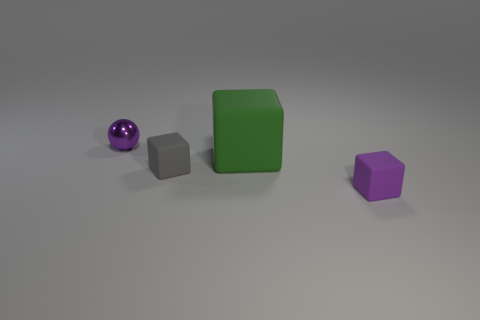Is there anything else that is the same size as the green matte thing?
Ensure brevity in your answer.  No. What is the size of the gray matte object?
Give a very brief answer. Small. There is a purple metal object that is left of the gray block; how big is it?
Give a very brief answer. Small. Does the object left of the gray object have the same size as the gray matte cube?
Ensure brevity in your answer.  Yes. Is there any other thing that is the same color as the metallic thing?
Make the answer very short. Yes. What is the shape of the big thing?
Keep it short and to the point. Cube. How many things are both to the left of the purple cube and on the right side of the sphere?
Provide a short and direct response. 2. Is the color of the metal sphere the same as the large rubber block?
Offer a terse response. No. What is the material of the small purple thing that is the same shape as the tiny gray matte thing?
Offer a very short reply. Rubber. Is there any other thing that is made of the same material as the small purple ball?
Offer a terse response. No. 